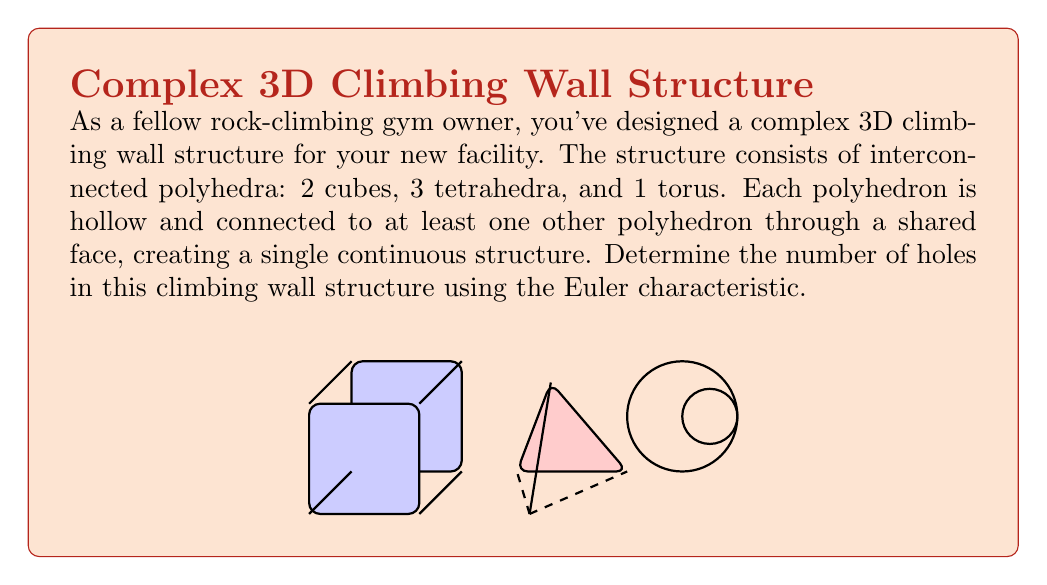Give your solution to this math problem. To determine the number of holes in this complex structure, we'll use the Euler characteristic formula for 3D objects:

$$\chi = V - E + F = 2 - 2g$$

Where:
$\chi$ is the Euler characteristic
$V$ is the number of vertices
$E$ is the number of edges
$F$ is the number of faces
$g$ is the genus (number of holes)

Let's count the components:

1. Cubes (2):
   - Vertices: 8 × 2 = 16
   - Edges: 12 × 2 = 24
   - Faces: 6 × 2 = 12

2. Tetrahedra (3):
   - Vertices: 4 × 3 = 12
   - Edges: 6 × 3 = 18
   - Faces: 4 × 3 = 12

3. Torus (1):
   - Vertices: 0
   - Edges: 0
   - Faces: 1 (outer surface)

Now, we need to account for the shared faces:
- Assume 5 shared faces (minimum for connecting all shapes)
- Shared faces reduce the total face count

Total components:
$V = 16 + 12 = 28$
$E = 24 + 18 = 42$
$F = (12 + 12 + 1) - 5 = 20$

Applying the Euler characteristic formula:

$$\chi = V - E + F = 28 - 42 + 20 = 6$$

Now we can solve for $g$:

$$6 = 2 - 2g$$
$$2g = -4$$
$$g = -2$$

The negative value of $g$ indicates that this structure has a positive contribution to the Euler characteristic, which is typical for objects with internal voids.

To find the actual number of holes, we add 1 to the absolute value of $g$:

Number of holes = $|-2| + 1 = 3$
Answer: 3 holes 